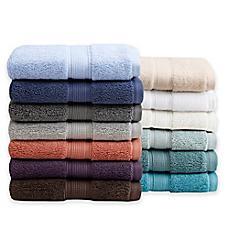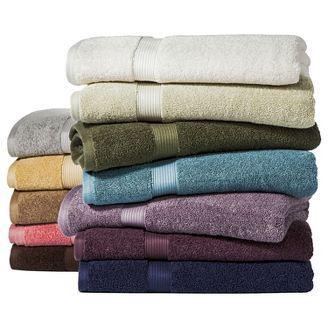The first image is the image on the left, the second image is the image on the right. Examine the images to the left and right. Is the description "Each image shows exactly two piles of multiple towels in different solid colors." accurate? Answer yes or no. Yes. 